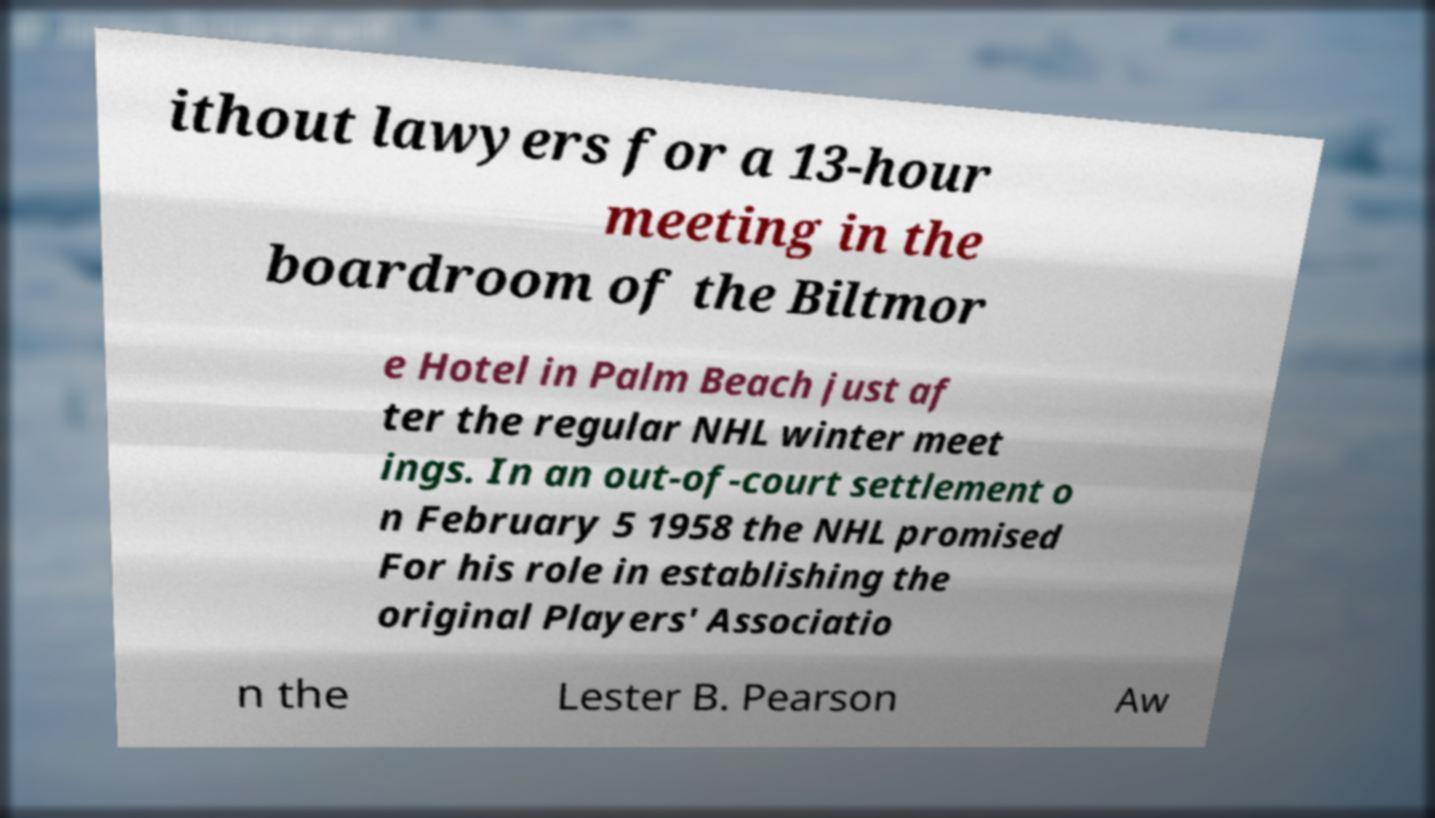I need the written content from this picture converted into text. Can you do that? ithout lawyers for a 13-hour meeting in the boardroom of the Biltmor e Hotel in Palm Beach just af ter the regular NHL winter meet ings. In an out-of-court settlement o n February 5 1958 the NHL promised For his role in establishing the original Players' Associatio n the Lester B. Pearson Aw 